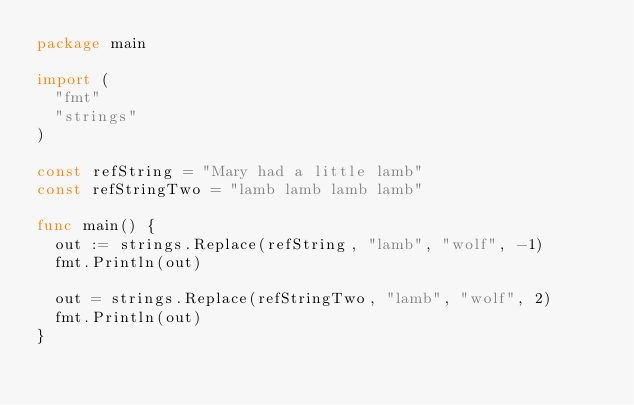Convert code to text. <code><loc_0><loc_0><loc_500><loc_500><_Go_>package main

import (
	"fmt"
	"strings"
)

const refString = "Mary had a little lamb"
const refStringTwo = "lamb lamb lamb lamb"

func main() {
	out := strings.Replace(refString, "lamb", "wolf", -1)
	fmt.Println(out)

	out = strings.Replace(refStringTwo, "lamb", "wolf", 2)
	fmt.Println(out)
}
</code> 